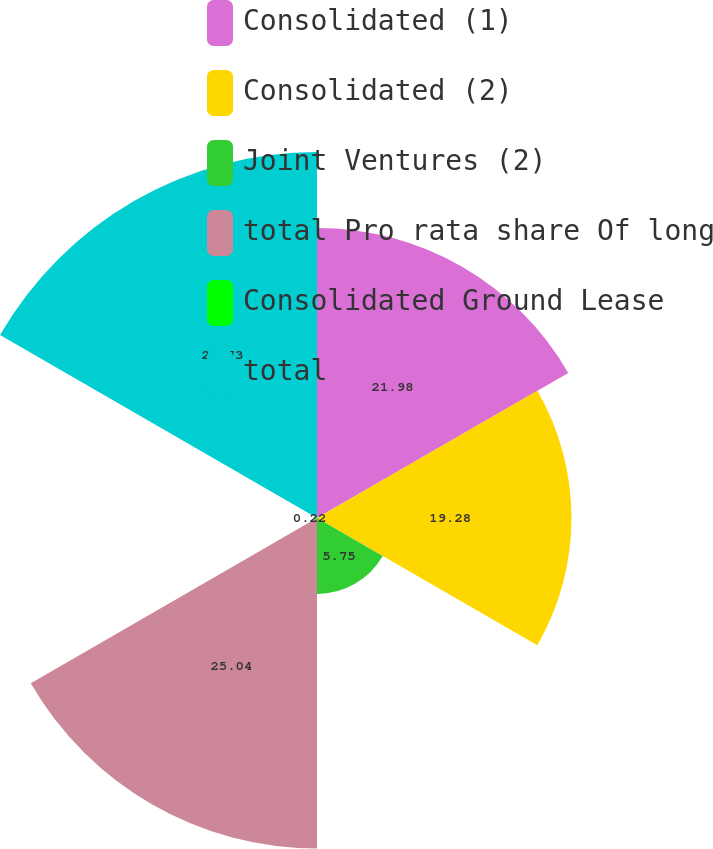<chart> <loc_0><loc_0><loc_500><loc_500><pie_chart><fcel>Consolidated (1)<fcel>Consolidated (2)<fcel>Joint Ventures (2)<fcel>total Pro rata share Of long<fcel>Consolidated Ground Lease<fcel>total<nl><fcel>21.98%<fcel>19.28%<fcel>5.75%<fcel>25.04%<fcel>0.22%<fcel>27.73%<nl></chart> 